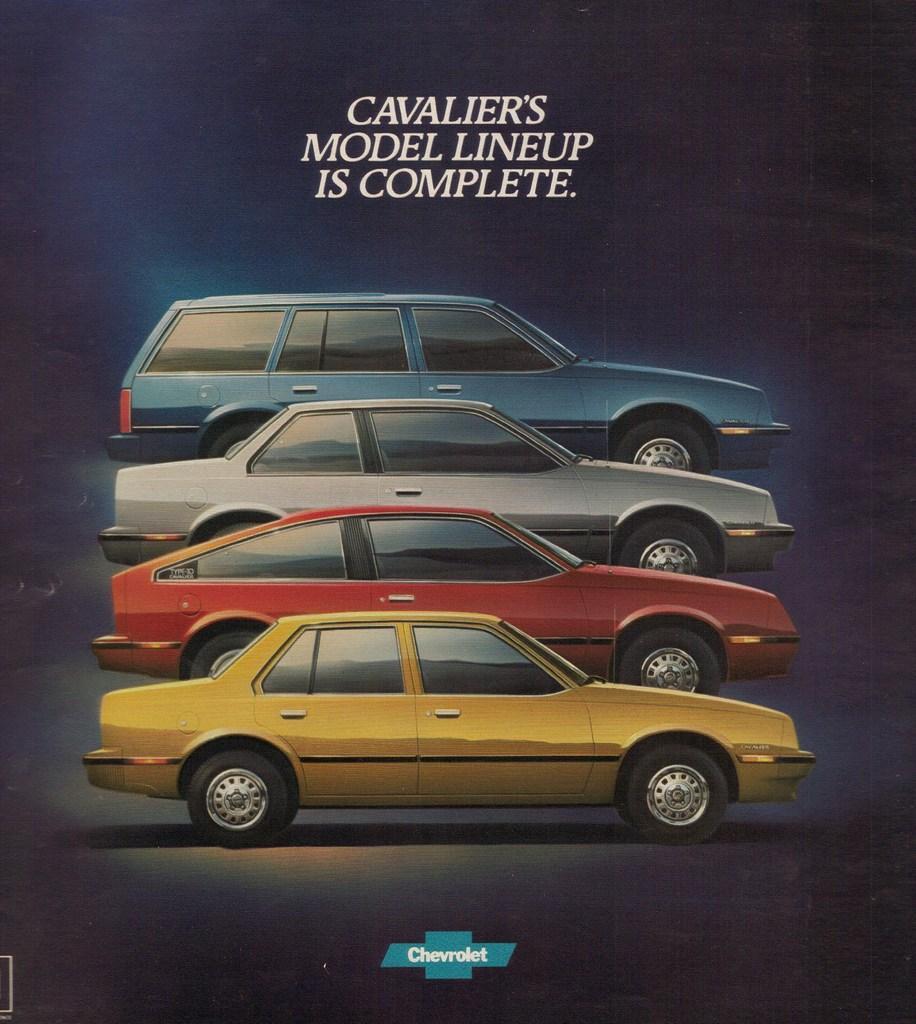Can you describe this image briefly? In this picture we can see four colorful cars in the magazine cover photo. On the top we can see "Model lineup is completed" is written. 